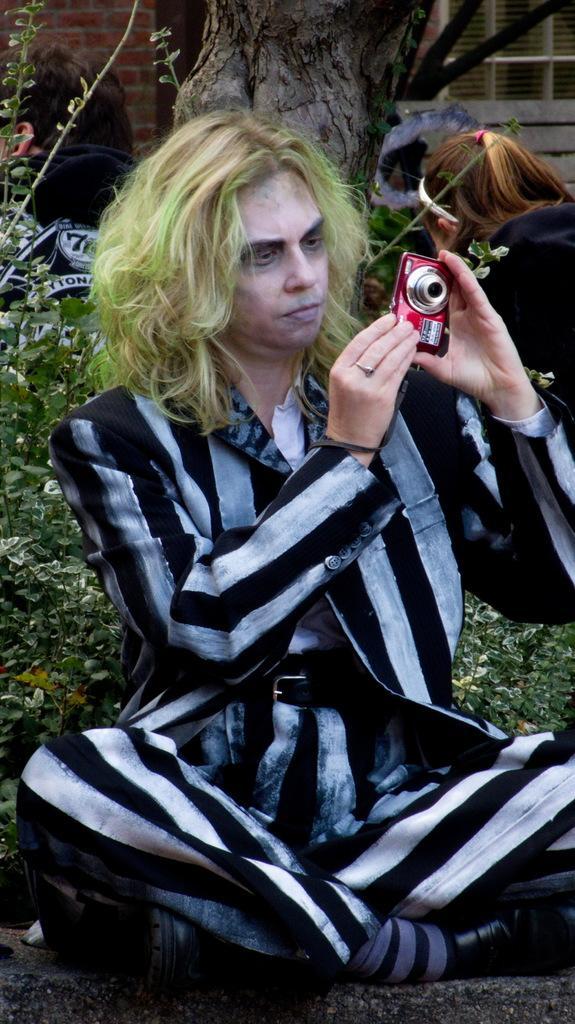Could you give a brief overview of what you see in this image? In the picture there is man with green color hair holding a camera in his hand ,sat on wall. In back side there is a tree and some plants. On to the right side corner there is a woman sat on wall. And on the whole background there is a building. 